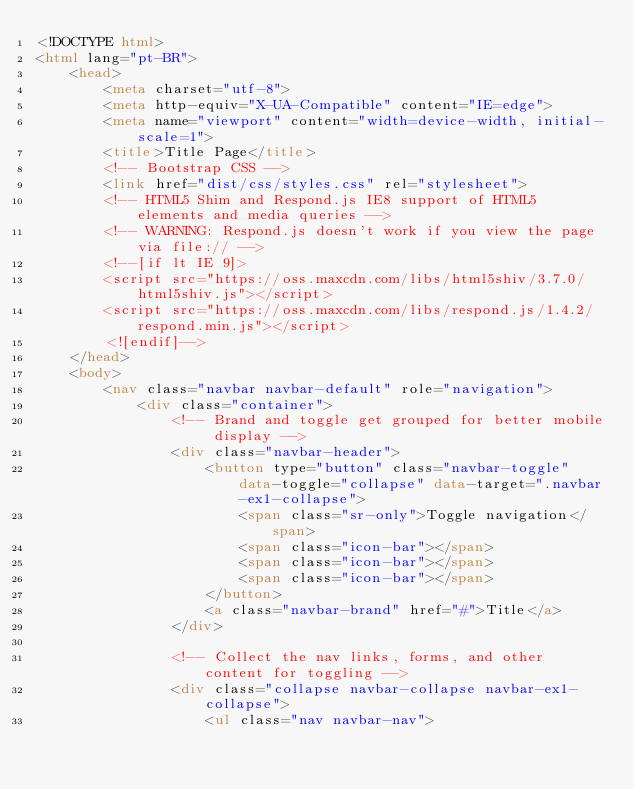<code> <loc_0><loc_0><loc_500><loc_500><_HTML_><!DOCTYPE html>
<html lang="pt-BR">
    <head>
        <meta charset="utf-8">
        <meta http-equiv="X-UA-Compatible" content="IE=edge">
        <meta name="viewport" content="width=device-width, initial-scale=1">
        <title>Title Page</title>
        <!-- Bootstrap CSS -->
        <link href="dist/css/styles.css" rel="stylesheet">
        <!-- HTML5 Shim and Respond.js IE8 support of HTML5 elements and media queries -->
        <!-- WARNING: Respond.js doesn't work if you view the page via file:// -->
        <!--[if lt IE 9]>
        <script src="https://oss.maxcdn.com/libs/html5shiv/3.7.0/html5shiv.js"></script>
        <script src="https://oss.maxcdn.com/libs/respond.js/1.4.2/respond.min.js"></script>
        <![endif]-->
    </head>
    <body>
        <nav class="navbar navbar-default" role="navigation">
            <div class="container">
                <!-- Brand and toggle get grouped for better mobile display -->
                <div class="navbar-header">
                    <button type="button" class="navbar-toggle" data-toggle="collapse" data-target=".navbar-ex1-collapse">
                        <span class="sr-only">Toggle navigation</span>
                        <span class="icon-bar"></span>
                        <span class="icon-bar"></span>
                        <span class="icon-bar"></span>
                    </button>
                    <a class="navbar-brand" href="#">Title</a>
                </div>
            
                <!-- Collect the nav links, forms, and other content for toggling -->
                <div class="collapse navbar-collapse navbar-ex1-collapse">
                    <ul class="nav navbar-nav"></code> 